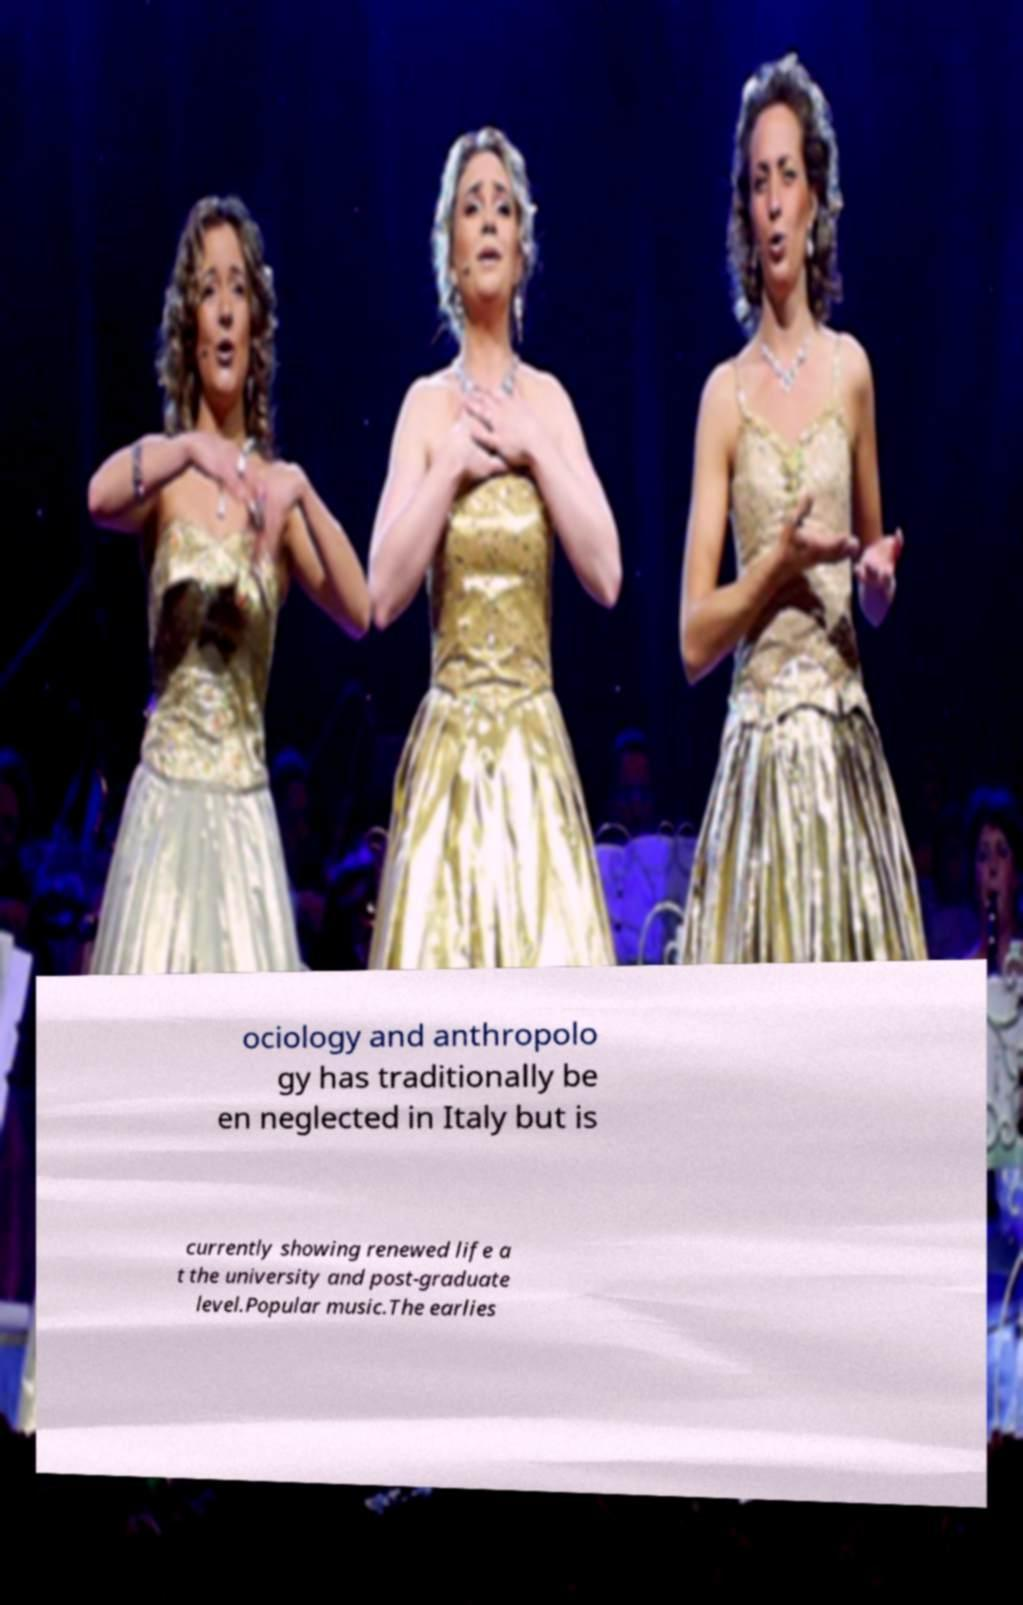Could you assist in decoding the text presented in this image and type it out clearly? ociology and anthropolo gy has traditionally be en neglected in Italy but is currently showing renewed life a t the university and post-graduate level.Popular music.The earlies 